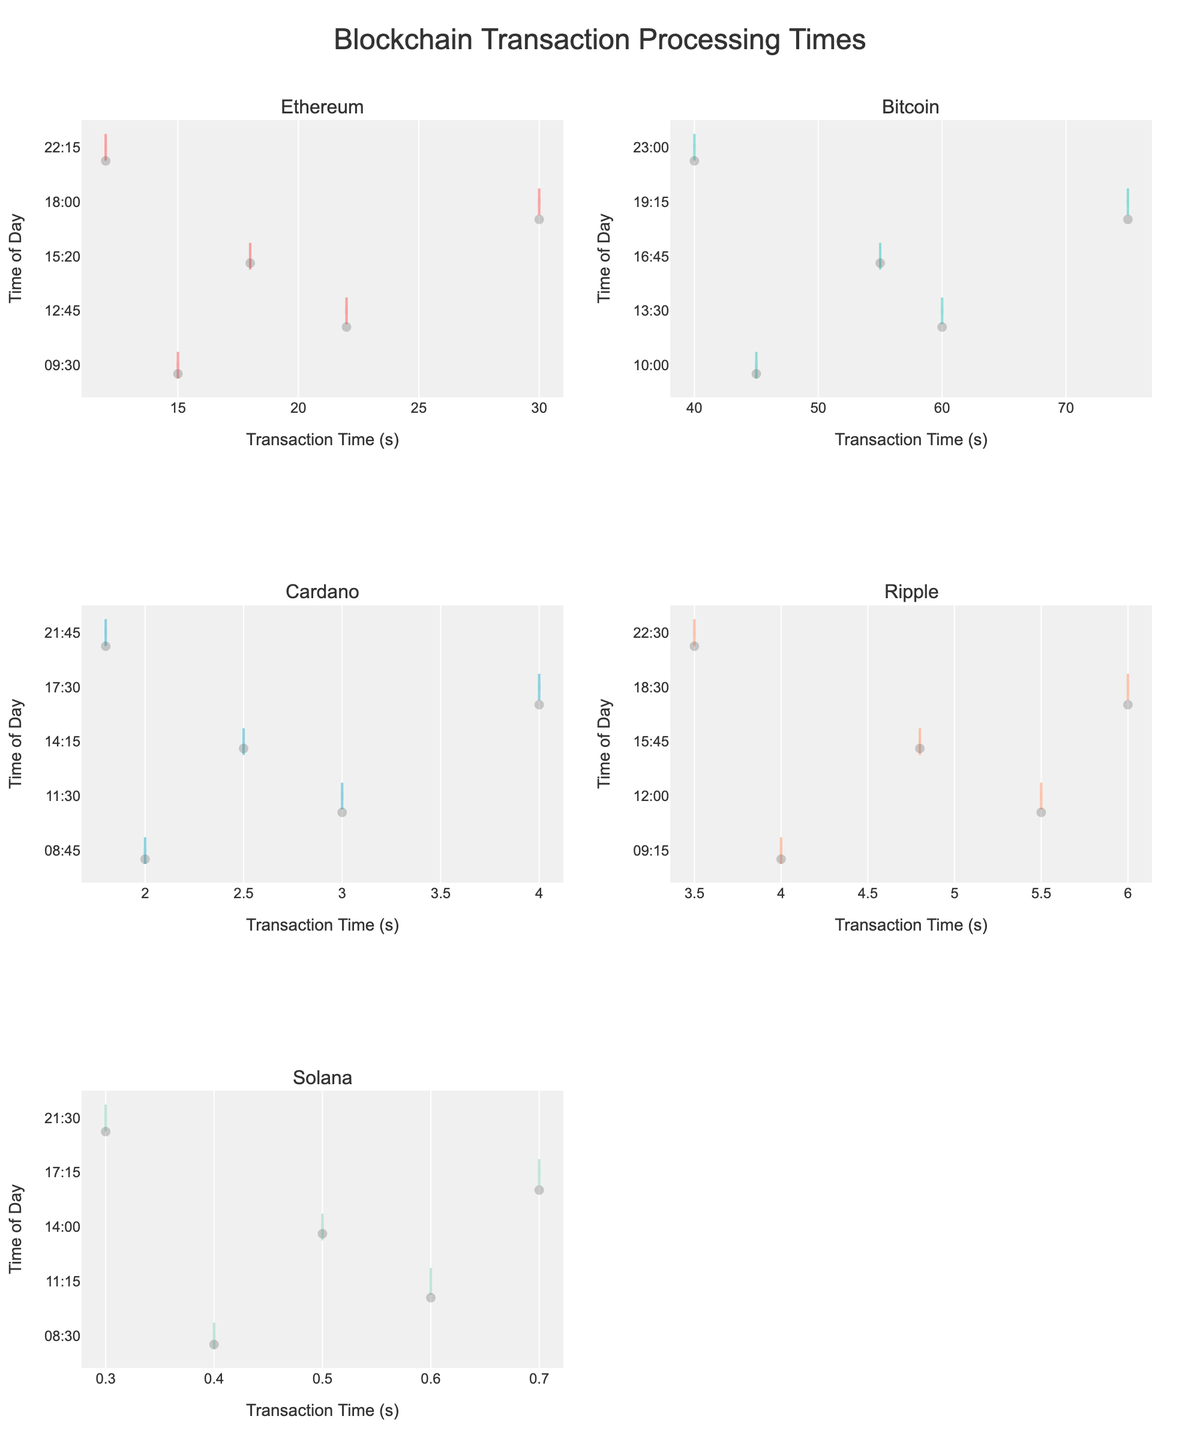Which network shows the highest transaction times in the morning? By looking at the density plots for each network, we can compare the transaction times around morning hours (approximately 8 AM to 10 AM). Bitcoin has data points indicating high transaction times in this period.
Answer: Bitcoin How does Ethereum's transaction time at 6 PM compare to its transaction time at 10 PM? By analyzing the plot for Ethereum, we see transaction times around 6 PM and 10 PM. At 6 PM, Ethereum's transaction time is higher at 30 seconds compared to around 10 PM which is about 12 seconds.
Answer: Higher at 6 PM What is the range of transaction times for Solana? The range is the difference between the maximum and minimum transaction times shown in the plot for Solana. The minimum is 0.3 seconds and the maximum is 0.7 seconds, so the range is 0.7 - 0.3 = 0.4 seconds.
Answer: 0.4 seconds Between Ripple and Cardano, which network has a narrower spread in transaction times? Comparing the spread of the density plots for Ripple and Cardano, Ripple's transaction times range from 3.5 to 6 seconds, while Cardano ranges from 1.8 to 4 seconds. Cardano has a narrower spread.
Answer: Cardano Do Ethereum and Bitcoin have any overlapping transaction times? By checking the density plots for Ethereum and Bitcoin, we notice that Ethereum’s transaction times are between 12 and 30 seconds, while Bitcoin ranges from 40 to 75 seconds. There is no overlap.
Answer: No What is the peak transaction time period for Bitcoin? To find the peak period, we need to observe the plot for Bitcoin and identify where the highest density of points occurs. Bitcoin shows peaks around 1 PM to 2 PM (13:00 to 14:00) and 7 PM (19:15).
Answer: 1 PM to 2 PM and 7 PM On which network do transactions tend to cluster very closely around one time duration? Solana's plot shows a very tight clustering of times between 0.3 and 0.7 seconds, indicating it has very consistent transaction times.
Answer: Solana At what time of day do Ethereum transactions appear to be the slowest? By examining Ethereum's plot and looking for the highest transaction time, we find it at around 6 PM where the transaction time peaks at 30 seconds.
Answer: 6 PM Which network has the quickest transactions in the evening (after 6 PM)? By evaluating the plots for all networks during the evening time period (after 6 PM), we see that Solana has transaction times significantly lower than the others, around 0.3 to 0.7 seconds.
Answer: Solana 